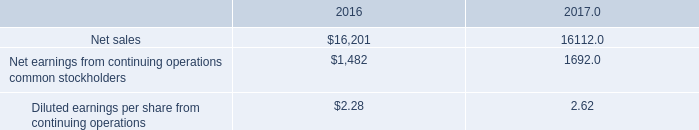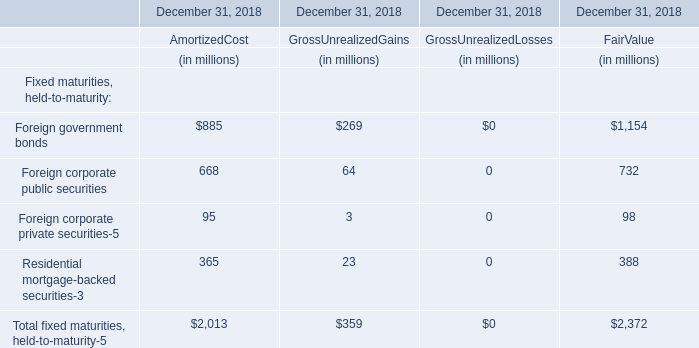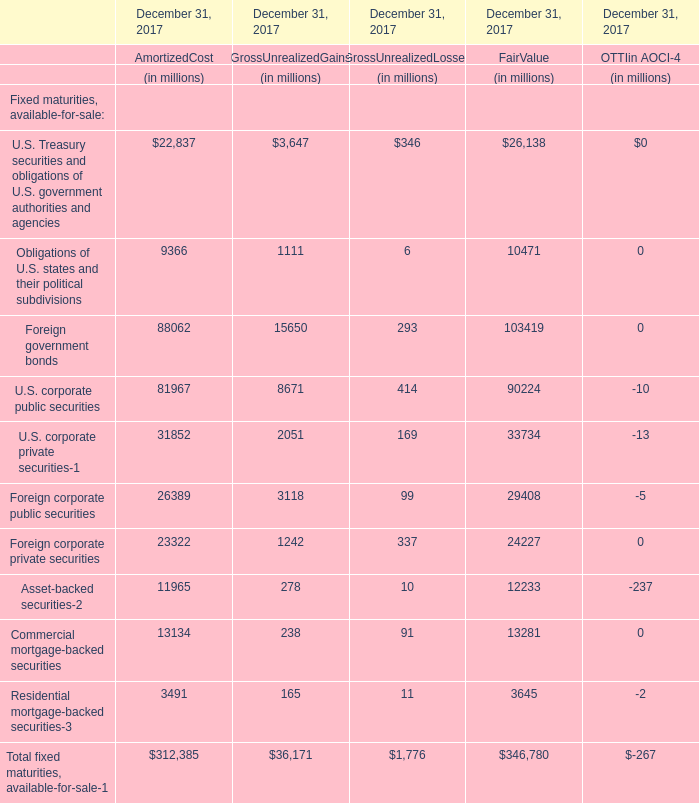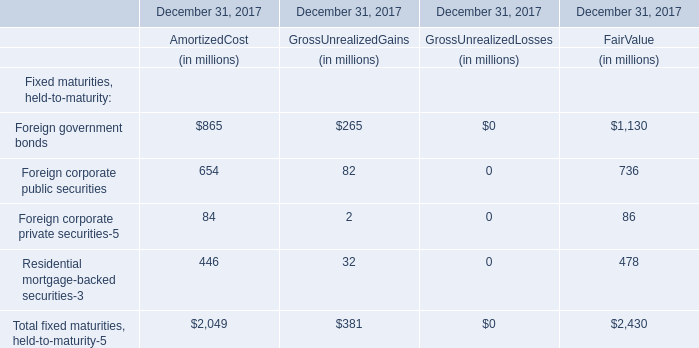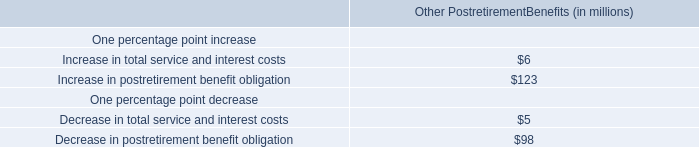What was the value of the Gross Unrealized Gains for Asset-backed securities at December 31, 2017? (in million) 
Answer: 278. 